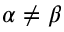<formula> <loc_0><loc_0><loc_500><loc_500>\alpha \neq \beta</formula> 